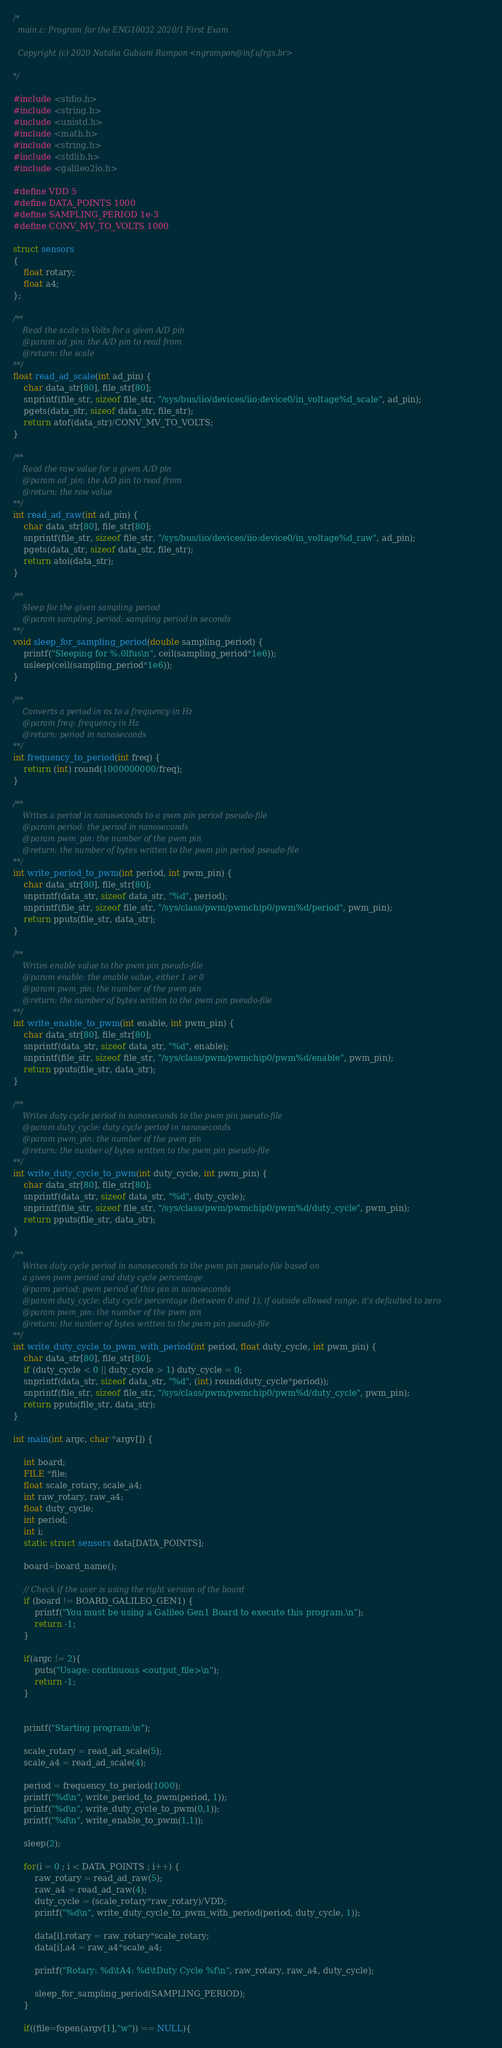Convert code to text. <code><loc_0><loc_0><loc_500><loc_500><_C_>/*
  main.c: Program for the ENG10032 2020/1 First Exam
  
  Copyright (c) 2020 Natalia Gubiani Rampon <ngrampon@inf.ufrgs.br>

*/

#include <stdio.h>
#include <string.h>
#include <unistd.h>
#include <math.h>
#include <string.h>
#include <stdlib.h>
#include <galileo2io.h>

#define VDD 5
#define DATA_POINTS 1000
#define SAMPLING_PERIOD 1e-3
#define CONV_MV_TO_VOLTS 1000

struct sensors
{
    float rotary;
    float a4;
};

/**
    Read the scale to Volts for a given A/D pin
    @param ad_pin: the A/D pin to read from
    @return: the scale
**/
float read_ad_scale(int ad_pin) {
    char data_str[80], file_str[80];
    snprintf(file_str, sizeof file_str, "/sys/bus/iio/devices/iio:device0/in_voltage%d_scale", ad_pin);
    pgets(data_str, sizeof data_str, file_str);
    return atof(data_str)/CONV_MV_TO_VOLTS;
}

/**
    Read the raw value for a given A/D pin
    @param ad_pin: the A/D pin to read from
    @return: the raw value
**/
int read_ad_raw(int ad_pin) {
    char data_str[80], file_str[80];
    snprintf(file_str, sizeof file_str, "/sys/bus/iio/devices/iio:device0/in_voltage%d_raw", ad_pin);
    pgets(data_str, sizeof data_str, file_str);
    return atoi(data_str);
}

/**
    Sleep for the given sampling period
    @param sampling_period: sampling period in seconds
**/
void sleep_for_sampling_period(double sampling_period) {
    printf("Sleeping for %.0lfus\n", ceil(sampling_period*1e6));
    usleep(ceil(sampling_period*1e6)); 
}

/**
    Converts a period in ns to a frequency in Hz
    @param freq: frequency in Hz
    @return: period in nanoseconds
**/
int frequency_to_period(int freq) {
    return (int) round(1000000000/freq);
}

/**
    Writes a period in nanoseconds to a pwm pin period pseudo-file
    @param period: the period in nanoseconds
    @param pwm_pin: the number of the pwm pin
    @return: the number of bytes written to the pwm pin period pseudo-file
**/
int write_period_to_pwm(int period, int pwm_pin) {
    char data_str[80], file_str[80];
    snprintf(data_str, sizeof data_str, "%d", period);
    snprintf(file_str, sizeof file_str, "/sys/class/pwm/pwmchip0/pwm%d/period", pwm_pin);
    return pputs(file_str, data_str);
}

/**
    Writes enable value to the pwm pin pseudo-file
    @param enable: the enable value, either 1 or 0
    @param pwm_pin: the number of the pwm pin
    @return: the number of bytes written to the pwm pin pseudo-file
**/
int write_enable_to_pwm(int enable, int pwm_pin) {
    char data_str[80], file_str[80];
    snprintf(data_str, sizeof data_str, "%d", enable);
    snprintf(file_str, sizeof file_str, "/sys/class/pwm/pwmchip0/pwm%d/enable", pwm_pin);
    return pputs(file_str, data_str);
}

/**
    Writes duty cycle period in nanoseconds to the pwm pin pseudo-file
    @param duty_cycle: duty cycle period in nanoseconds
    @param pwm_pin: the number of the pwm pin
    @return: the nunber of bytes written to the pwm pin pseudo-file
**/
int write_duty_cycle_to_pwm(int duty_cycle, int pwm_pin) {
    char data_str[80], file_str[80];
    snprintf(data_str, sizeof data_str, "%d", duty_cycle);
    snprintf(file_str, sizeof file_str, "/sys/class/pwm/pwmchip0/pwm%d/duty_cycle", pwm_pin);
    return pputs(file_str, data_str);
}

/**
    Writes duty cycle period in nanoseconds to the pwm pin pseudo-file based on
    a given pwm period and duty cycle percentage
    @parm period: pwm period of this pin in nanoseconds
    @param duty_cycle: duty cycle percentage (between 0 and 1), if outside allowed range, it's defaulted to zero
    @param pwm_pin: the number of the pwm pin
    @return: the nunber of bytes written to the pwm pin pseudo-file
**/
int write_duty_cycle_to_pwm_with_period(int period, float duty_cycle, int pwm_pin) {
    char data_str[80], file_str[80];
    if (duty_cycle < 0 || duty_cycle > 1) duty_cycle = 0;
    snprintf(data_str, sizeof data_str, "%d", (int) round(duty_cycle*period));
    snprintf(file_str, sizeof file_str, "/sys/class/pwm/pwmchip0/pwm%d/duty_cycle", pwm_pin);
    return pputs(file_str, data_str);
}

int main(int argc, char *argv[]) {

    int board;
    FILE *file;
    float scale_rotary, scale_a4;
    int raw_rotary, raw_a4;
    float duty_cycle;
    int period;
    int i;
    static struct sensors data[DATA_POINTS];

    board=board_name();

    // Check if the user is using the right version of the board
    if (board != BOARD_GALILEO_GEN1) {
        printf("You must be using a Galileo Gen1 Board to execute this program.\n");
        return -1;
    }

    if(argc != 2){
        puts("Usage: continuous <output_file>\n");
        return -1;
    }


    printf("Starting program:\n");

    scale_rotary = read_ad_scale(5);
    scale_a4 = read_ad_scale(4);

    period = frequency_to_period(1000);
    printf("%d\n", write_period_to_pwm(period, 1));
    printf("%d\n", write_duty_cycle_to_pwm(0,1));
    printf("%d\n", write_enable_to_pwm(1,1));

    sleep(2);

    for(i = 0 ; i < DATA_POINTS ; i++) {
        raw_rotary = read_ad_raw(5);
        raw_a4 = read_ad_raw(4);
        duty_cycle = (scale_rotary*raw_rotary)/VDD;
        printf("%d\n", write_duty_cycle_to_pwm_with_period(period, duty_cycle, 1));
        
        data[i].rotary = raw_rotary*scale_rotary;
        data[i].a4 = raw_a4*scale_a4;

        printf("Rotary: %d\tA4: %d\tDuty Cycle %f\n", raw_rotary, raw_a4, duty_cycle);
        
        sleep_for_sampling_period(SAMPLING_PERIOD);
    }

    if((file=fopen(argv[1],"w")) == NULL){</code> 